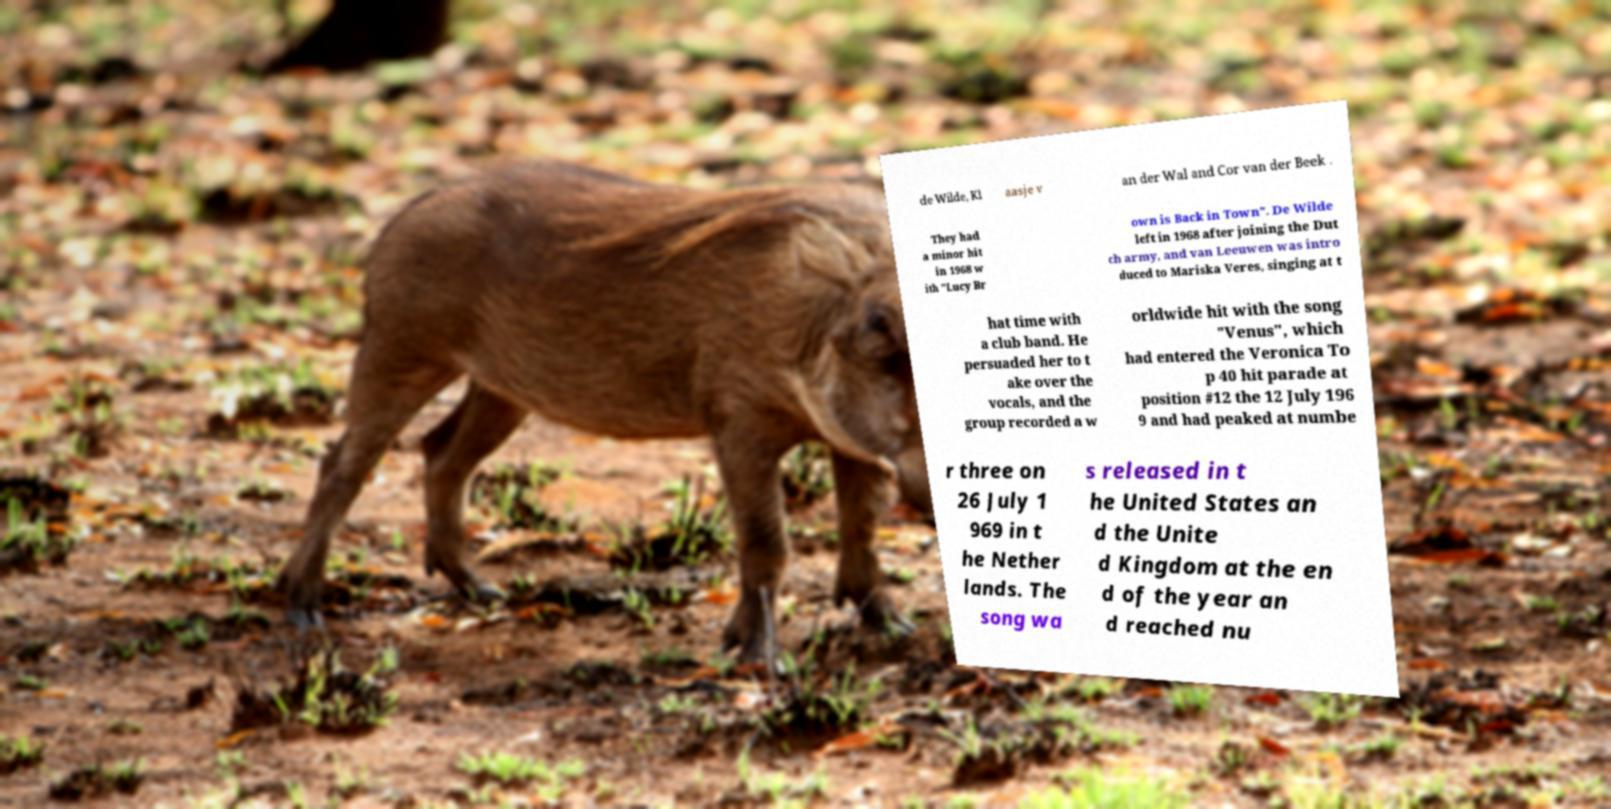There's text embedded in this image that I need extracted. Can you transcribe it verbatim? de Wilde, Kl aasje v an der Wal and Cor van der Beek . They had a minor hit in 1968 w ith "Lucy Br own is Back in Town". De Wilde left in 1968 after joining the Dut ch army, and van Leeuwen was intro duced to Mariska Veres, singing at t hat time with a club band. He persuaded her to t ake over the vocals, and the group recorded a w orldwide hit with the song "Venus", which had entered the Veronica To p 40 hit parade at position #12 the 12 July 196 9 and had peaked at numbe r three on 26 July 1 969 in t he Nether lands. The song wa s released in t he United States an d the Unite d Kingdom at the en d of the year an d reached nu 